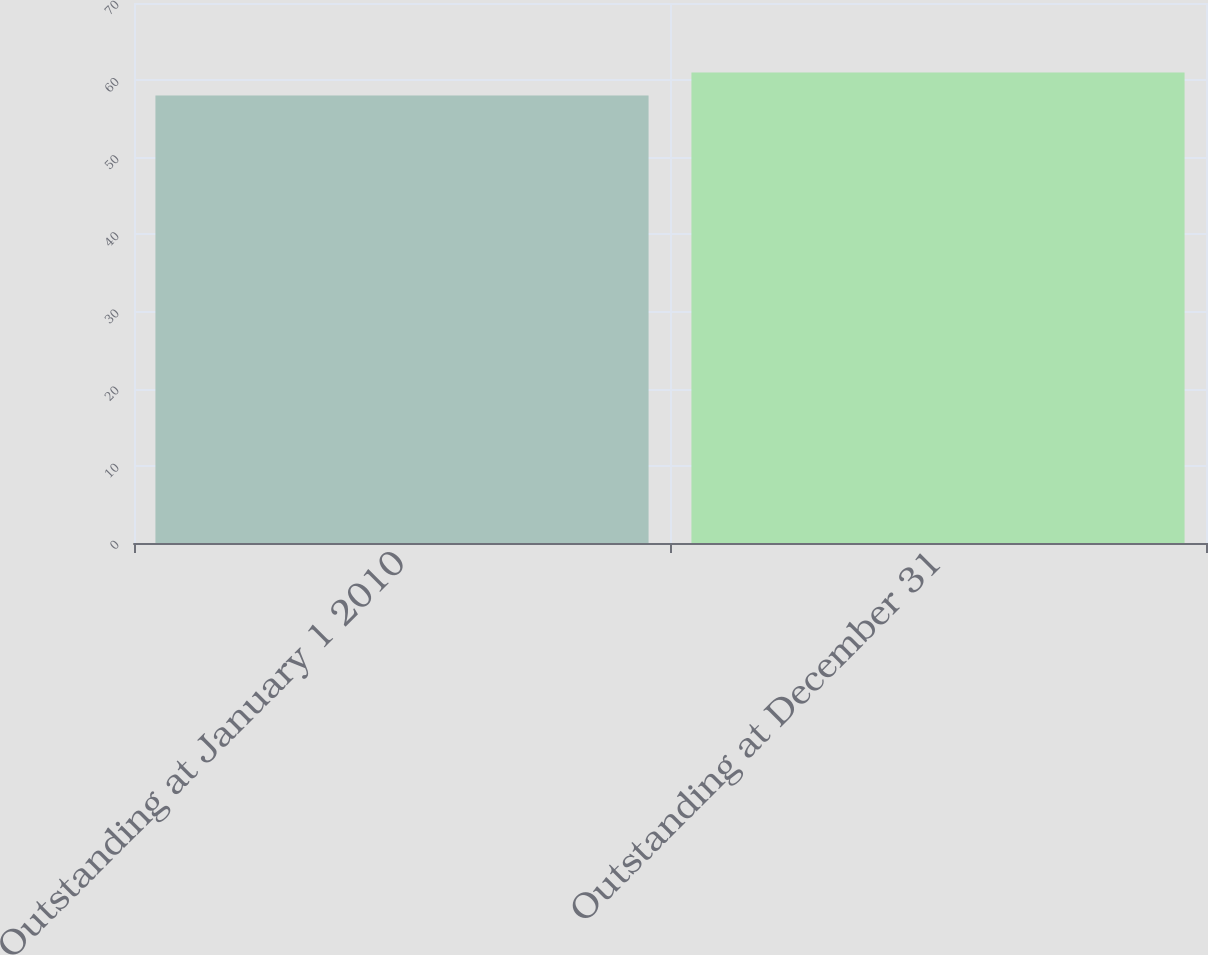<chart> <loc_0><loc_0><loc_500><loc_500><bar_chart><fcel>Outstanding at January 1 2010<fcel>Outstanding at December 31<nl><fcel>58<fcel>61<nl></chart> 